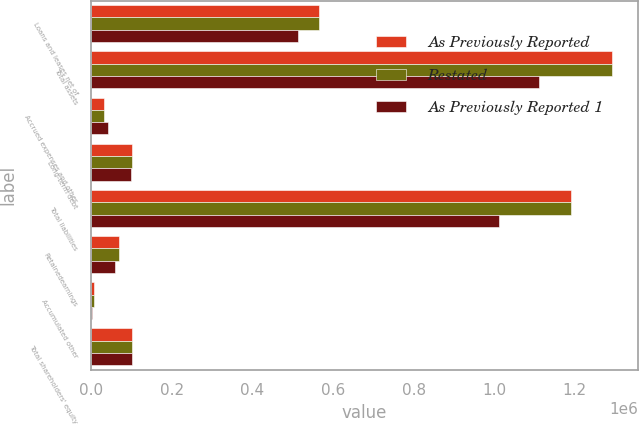<chart> <loc_0><loc_0><loc_500><loc_500><stacked_bar_chart><ecel><fcel>Loans and leases net of<fcel>Total assets<fcel>Accrued expenses and other<fcel>Long-term debt<fcel>Total liabilities<fcel>Retainedearnings<fcel>Accumulated other<fcel>Total shareholders' equity<nl><fcel>As Previously Reported<fcel>565737<fcel>1.2918e+06<fcel>31749<fcel>101338<fcel>1.19057e+06<fcel>67205<fcel>7518<fcel>101224<nl><fcel>Restated<fcel>565746<fcel>1.2918e+06<fcel>31938<fcel>100848<fcel>1.19027e+06<fcel>67552<fcel>7556<fcel>101533<nl><fcel>As Previously Reported 1<fcel>513211<fcel>1.11046e+06<fcel>41243<fcel>98078<fcel>1.01081e+06<fcel>58006<fcel>2587<fcel>99645<nl></chart> 